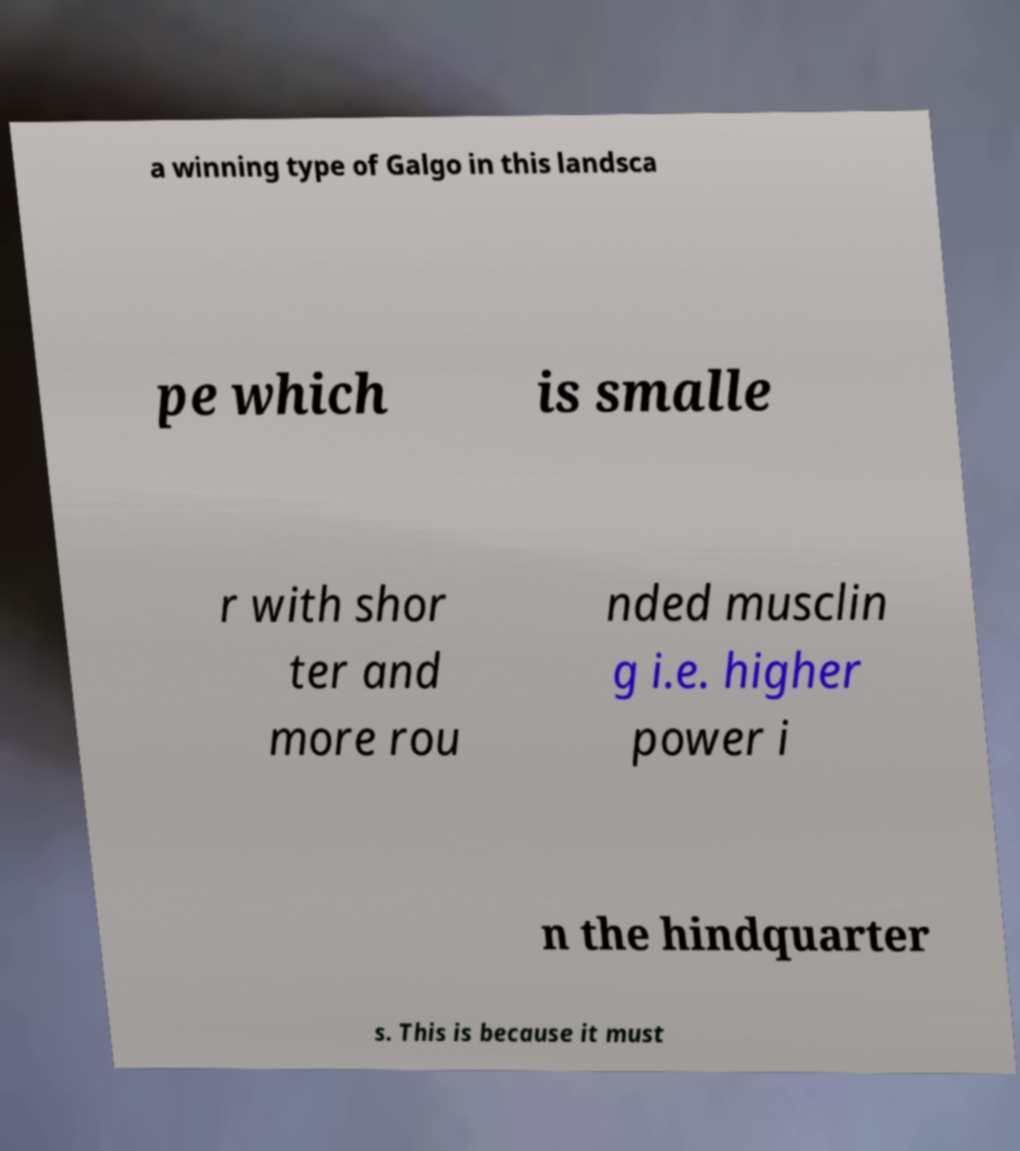Can you read and provide the text displayed in the image?This photo seems to have some interesting text. Can you extract and type it out for me? a winning type of Galgo in this landsca pe which is smalle r with shor ter and more rou nded musclin g i.e. higher power i n the hindquarter s. This is because it must 